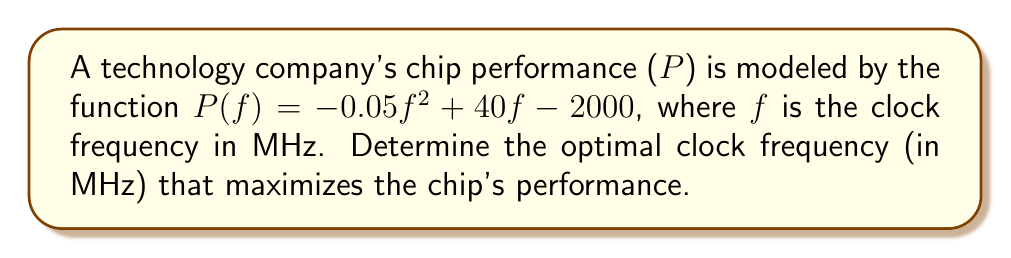Can you answer this question? To find the optimal clock frequency that maximizes the chip's performance, we need to find the maximum point of the given quadratic function. This can be done by following these steps:

1. The function $P(f) = -0.05f^2 + 40f - 2000$ is a quadratic function in the form $af^2 + bf + c$, where:
   $a = -0.05$
   $b = 40$
   $c = -2000$

2. For a quadratic function, the maximum (or minimum) occurs at the vertex. The f-coordinate of the vertex can be found using the formula: $f = -\frac{b}{2a}$

3. Substituting the values:
   $$f = -\frac{40}{2(-0.05)} = -\frac{40}{-0.1} = 400$$

4. To confirm this is a maximum (not a minimum), we can observe that $a < 0$, which means the parabola opens downward, and the vertex is indeed a maximum point.

Therefore, the optimal clock frequency that maximizes the chip's performance is 400 MHz.
Answer: 400 MHz 